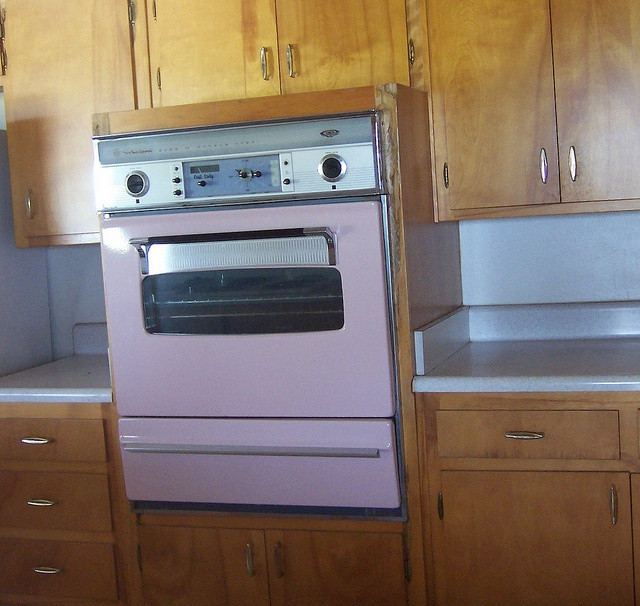Describe the objects in this image and their specific colors. I can see a oven in tan, darkgray, gray, and black tones in this image. 